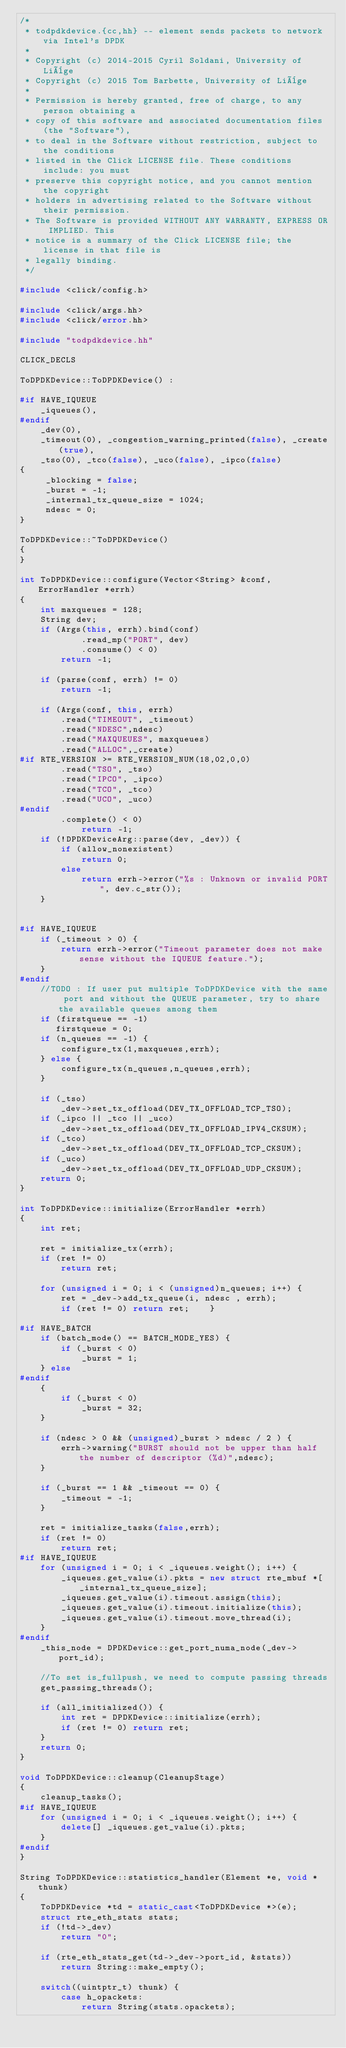Convert code to text. <code><loc_0><loc_0><loc_500><loc_500><_C++_>/*
 * todpdkdevice.{cc,hh} -- element sends packets to network via Intel's DPDK
 *
 * Copyright (c) 2014-2015 Cyril Soldani, University of Liège
 * Copyright (c) 2015 Tom Barbette, University of Liège
 *
 * Permission is hereby granted, free of charge, to any person obtaining a
 * copy of this software and associated documentation files (the "Software"),
 * to deal in the Software without restriction, subject to the conditions
 * listed in the Click LICENSE file. These conditions include: you must
 * preserve this copyright notice, and you cannot mention the copyright
 * holders in advertising related to the Software without their permission.
 * The Software is provided WITHOUT ANY WARRANTY, EXPRESS OR IMPLIED. This
 * notice is a summary of the Click LICENSE file; the license in that file is
 * legally binding.
 */

#include <click/config.h>

#include <click/args.hh>
#include <click/error.hh>

#include "todpdkdevice.hh"

CLICK_DECLS

ToDPDKDevice::ToDPDKDevice() :

#if HAVE_IQUEUE
    _iqueues(),
#endif
    _dev(0),
    _timeout(0), _congestion_warning_printed(false), _create(true),
    _tso(0), _tco(false), _uco(false), _ipco(false)
{
     _blocking = false;
     _burst = -1;
     _internal_tx_queue_size = 1024;
     ndesc = 0;
}

ToDPDKDevice::~ToDPDKDevice()
{
}

int ToDPDKDevice::configure(Vector<String> &conf, ErrorHandler *errh)
{
    int maxqueues = 128;
    String dev;
    if (Args(this, errh).bind(conf)
            .read_mp("PORT", dev)
            .consume() < 0)
        return -1;

    if (parse(conf, errh) != 0)
        return -1;

    if (Args(conf, this, errh)
        .read("TIMEOUT", _timeout)
        .read("NDESC",ndesc)
        .read("MAXQUEUES", maxqueues)
        .read("ALLOC",_create)
#if RTE_VERSION >= RTE_VERSION_NUM(18,02,0,0)
        .read("TSO", _tso)
        .read("IPCO", _ipco)
        .read("TCO", _tco)
        .read("UCO", _uco)
#endif
        .complete() < 0)
            return -1;
    if (!DPDKDeviceArg::parse(dev, _dev)) {
        if (allow_nonexistent)
            return 0;
        else
            return errh->error("%s : Unknown or invalid PORT", dev.c_str());
    }


#if HAVE_IQUEUE
    if (_timeout > 0) {
        return errh->error("Timeout parameter does not make sense without the IQUEUE feature.");
    }
#endif
    //TODO : If user put multiple ToDPDKDevice with the same port and without the QUEUE parameter, try to share the available queues among them
    if (firstqueue == -1)
       firstqueue = 0;
    if (n_queues == -1) {
        configure_tx(1,maxqueues,errh);
    } else {
        configure_tx(n_queues,n_queues,errh);
    }

    if (_tso)
        _dev->set_tx_offload(DEV_TX_OFFLOAD_TCP_TSO);
    if (_ipco || _tco || _uco)
        _dev->set_tx_offload(DEV_TX_OFFLOAD_IPV4_CKSUM);
    if (_tco)
        _dev->set_tx_offload(DEV_TX_OFFLOAD_TCP_CKSUM);
    if (_uco)
        _dev->set_tx_offload(DEV_TX_OFFLOAD_UDP_CKSUM);
    return 0;
}

int ToDPDKDevice::initialize(ErrorHandler *errh)
{
    int ret;

    ret = initialize_tx(errh);
    if (ret != 0)
        return ret;

    for (unsigned i = 0; i < (unsigned)n_queues; i++) {
        ret = _dev->add_tx_queue(i, ndesc , errh);
        if (ret != 0) return ret;    }

#if HAVE_BATCH
    if (batch_mode() == BATCH_MODE_YES) {
        if (_burst < 0)
            _burst = 1;
    } else
#endif
    {
        if (_burst < 0)
            _burst = 32;
    }

    if (ndesc > 0 && (unsigned)_burst > ndesc / 2 ) {
        errh->warning("BURST should not be upper than half the number of descriptor (%d)",ndesc);
    }

    if (_burst == 1 && _timeout == 0) {
        _timeout = -1;
    }

    ret = initialize_tasks(false,errh);
    if (ret != 0)
        return ret;
#if HAVE_IQUEUE
    for (unsigned i = 0; i < _iqueues.weight(); i++) {
        _iqueues.get_value(i).pkts = new struct rte_mbuf *[_internal_tx_queue_size];
        _iqueues.get_value(i).timeout.assign(this);
        _iqueues.get_value(i).timeout.initialize(this);
        _iqueues.get_value(i).timeout.move_thread(i);
    }
#endif
    _this_node = DPDKDevice::get_port_numa_node(_dev->port_id);

    //To set is_fullpush, we need to compute passing threads
    get_passing_threads();

    if (all_initialized()) {
        int ret = DPDKDevice::initialize(errh);
        if (ret != 0) return ret;
    }
    return 0;
}

void ToDPDKDevice::cleanup(CleanupStage)
{
    cleanup_tasks();
#if HAVE_IQUEUE
    for (unsigned i = 0; i < _iqueues.weight(); i++) {
        delete[] _iqueues.get_value(i).pkts;
    }
#endif
}

String ToDPDKDevice::statistics_handler(Element *e, void * thunk)
{
    ToDPDKDevice *td = static_cast<ToDPDKDevice *>(e);
    struct rte_eth_stats stats;
    if (!td->_dev)
        return "0";

    if (rte_eth_stats_get(td->_dev->port_id, &stats))
        return String::make_empty();

    switch((uintptr_t) thunk) {
        case h_opackets:
            return String(stats.opackets);</code> 